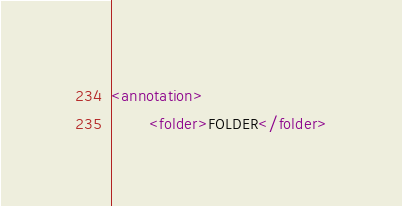<code> <loc_0><loc_0><loc_500><loc_500><_XML_><annotation>
        <folder>FOLDER</folder></code> 